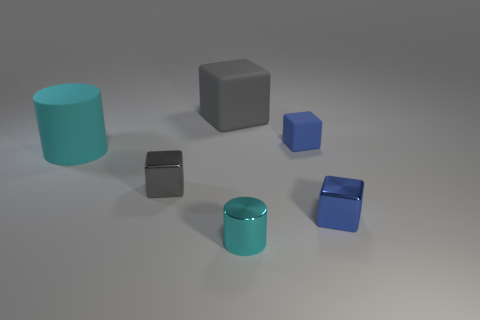How many objects are displayed in the image? There are six objects displayed in the image, consisting of different shapes and two colors. 